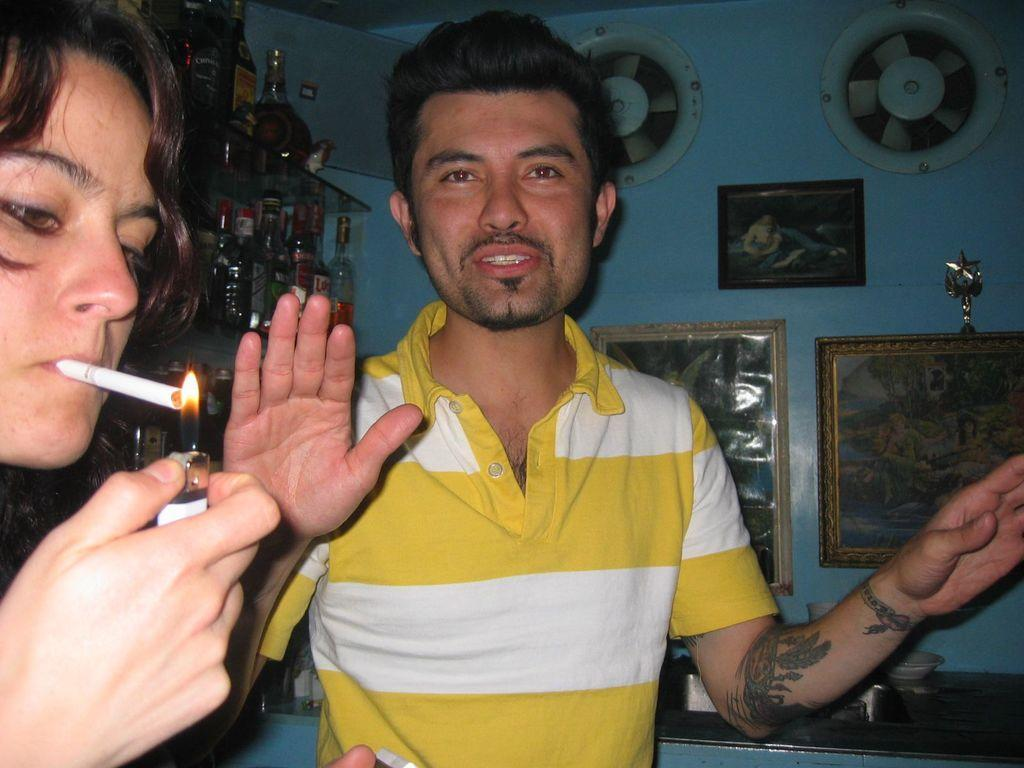What is the primary action being performed by the person in the image? A woman is lighting a cigarette in the image. What objects are related to the consumption of alcohol in the image? There are wine bottles on a glass rack in the image. What type of decorative items can be seen on the wall? There are photo frames on the wall in the image. What color is the suit worn by the person holding the pail in the image? There is no person holding a pail in the image, and no one is wearing a suit. 